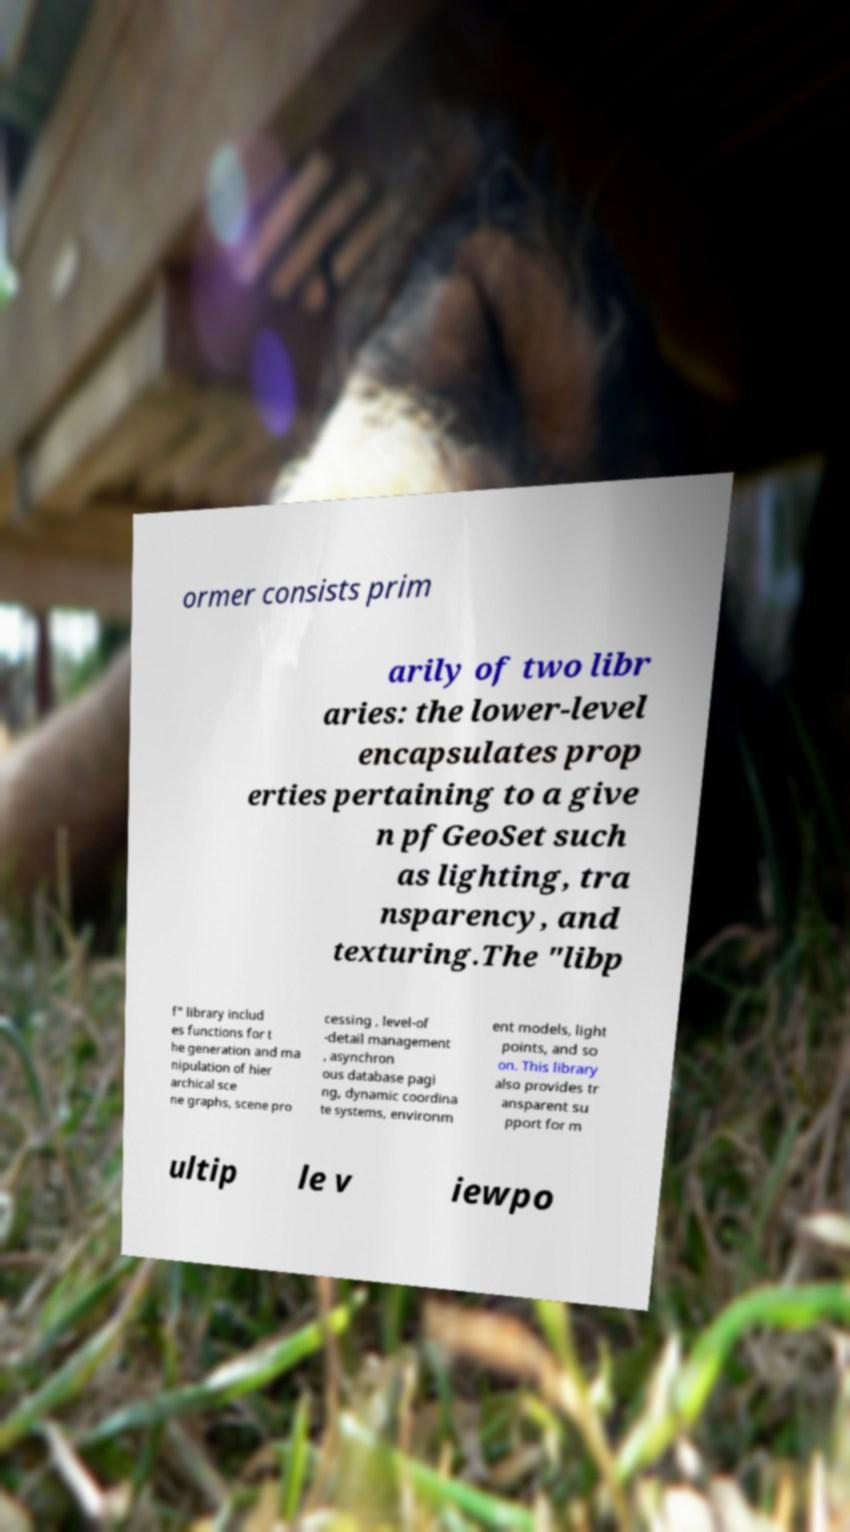For documentation purposes, I need the text within this image transcribed. Could you provide that? ormer consists prim arily of two libr aries: the lower-level encapsulates prop erties pertaining to a give n pfGeoSet such as lighting, tra nsparency, and texturing.The "libp f" library includ es functions for t he generation and ma nipulation of hier archical sce ne graphs, scene pro cessing , level-of -detail management , asynchron ous database pagi ng, dynamic coordina te systems, environm ent models, light points, and so on. This library also provides tr ansparent su pport for m ultip le v iewpo 